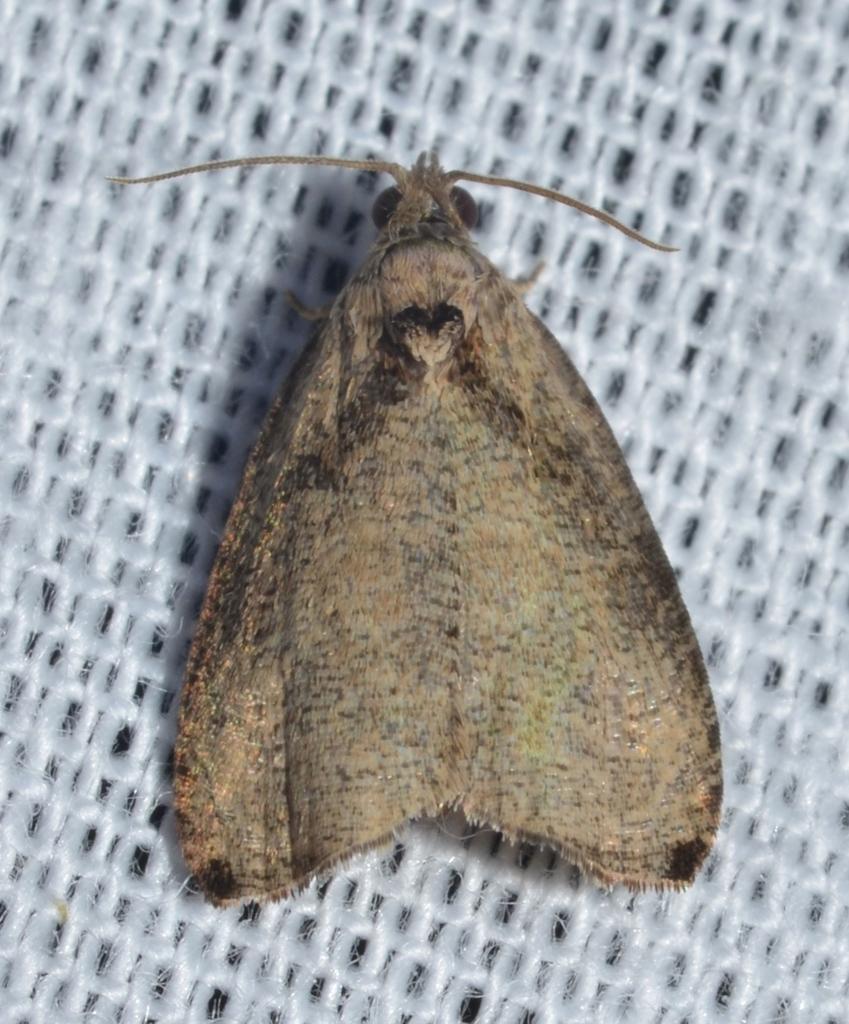How would you summarize this image in a sentence or two? Here we can see an insect on white mesh. 